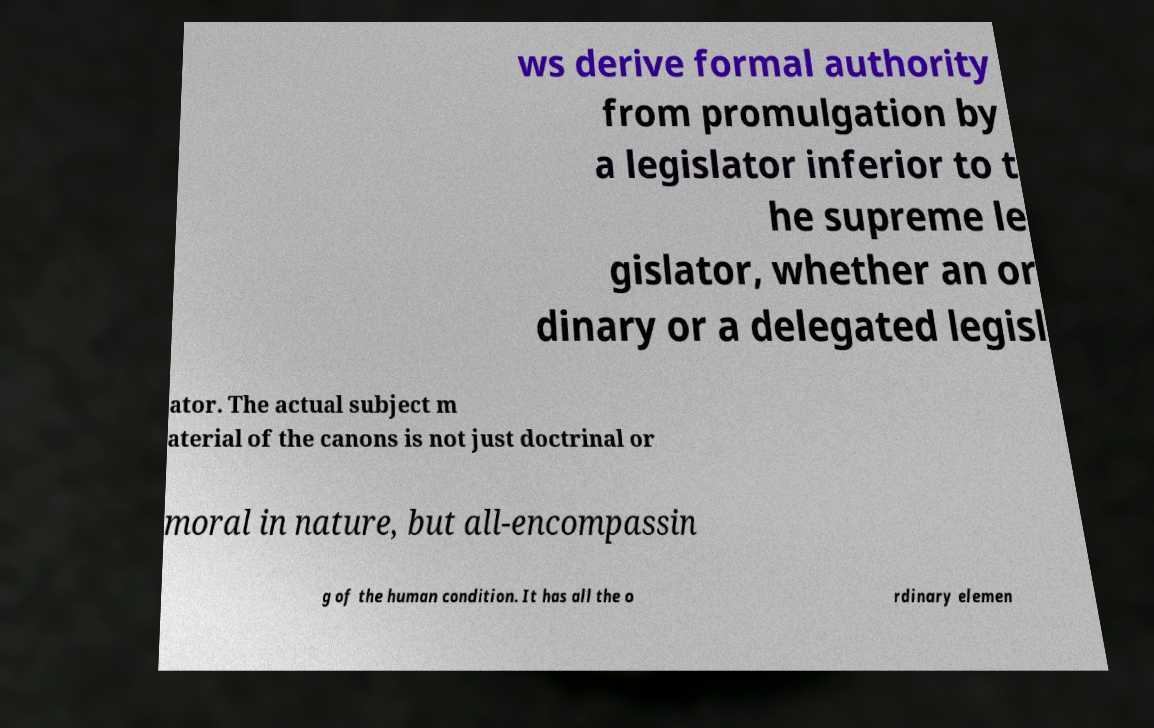What messages or text are displayed in this image? I need them in a readable, typed format. ws derive formal authority from promulgation by a legislator inferior to t he supreme le gislator, whether an or dinary or a delegated legisl ator. The actual subject m aterial of the canons is not just doctrinal or moral in nature, but all-encompassin g of the human condition. It has all the o rdinary elemen 